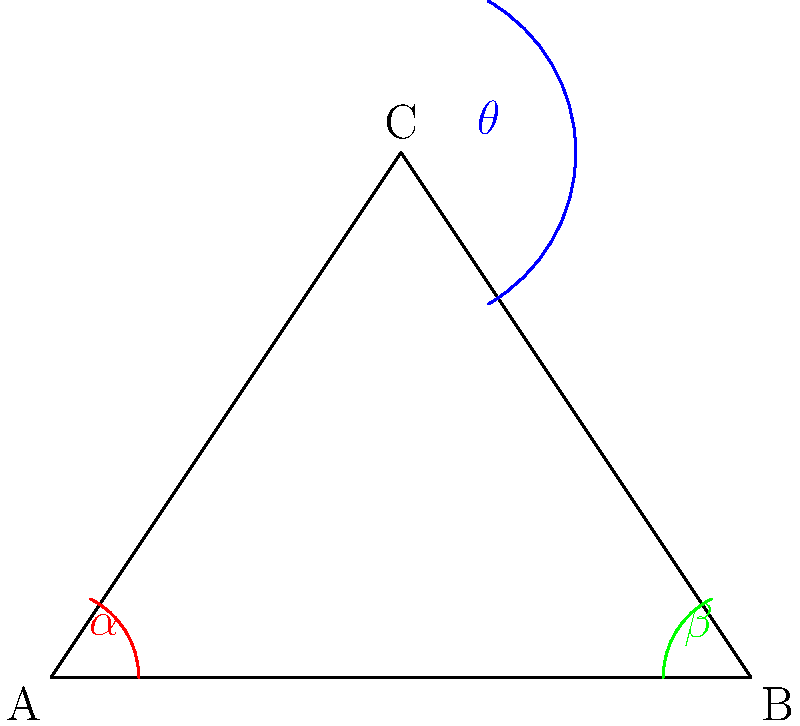In a novel fungal bioreactor design, the growth chamber is shaped like an isosceles triangle ABC, where AC = BC. The angle at the apex (C) is denoted as $\theta$. If the base angles of the triangle (at A and B) are $\alpha$ and $\beta$ respectively, what is the relationship between $\theta$, $\alpha$, and $\beta$? Let's approach this step-by-step:

1) In an isosceles triangle, the base angles are equal. Therefore, $\alpha = \beta$.

2) In any triangle, the sum of all interior angles is always 180°. We can express this as:

   $\theta + \alpha + \beta = 180°$

3) Since $\alpha = \beta$, we can rewrite this as:

   $\theta + 2\alpha = 180°$

4) To express $\theta$ in terms of $\alpha$:

   $\theta = 180° - 2\alpha$

5) Alternatively, to express $\alpha$ in terms of $\theta$:

   $2\alpha = 180° - \theta$
   $\alpha = \frac{180° - \theta}{2}$

6) Since $\beta = \alpha$, the same relationship applies for $\beta$:

   $\beta = \frac{180° - \theta}{2}$

Therefore, the relationship between $\theta$, $\alpha$, and $\beta$ in this isosceles triangular bioreactor design is:

$\theta = 180° - 2\alpha = 180° - 2\beta$

or

$\alpha = \beta = \frac{180° - \theta}{2}$
Answer: $\theta = 180° - 2\alpha = 180° - 2\beta$ 